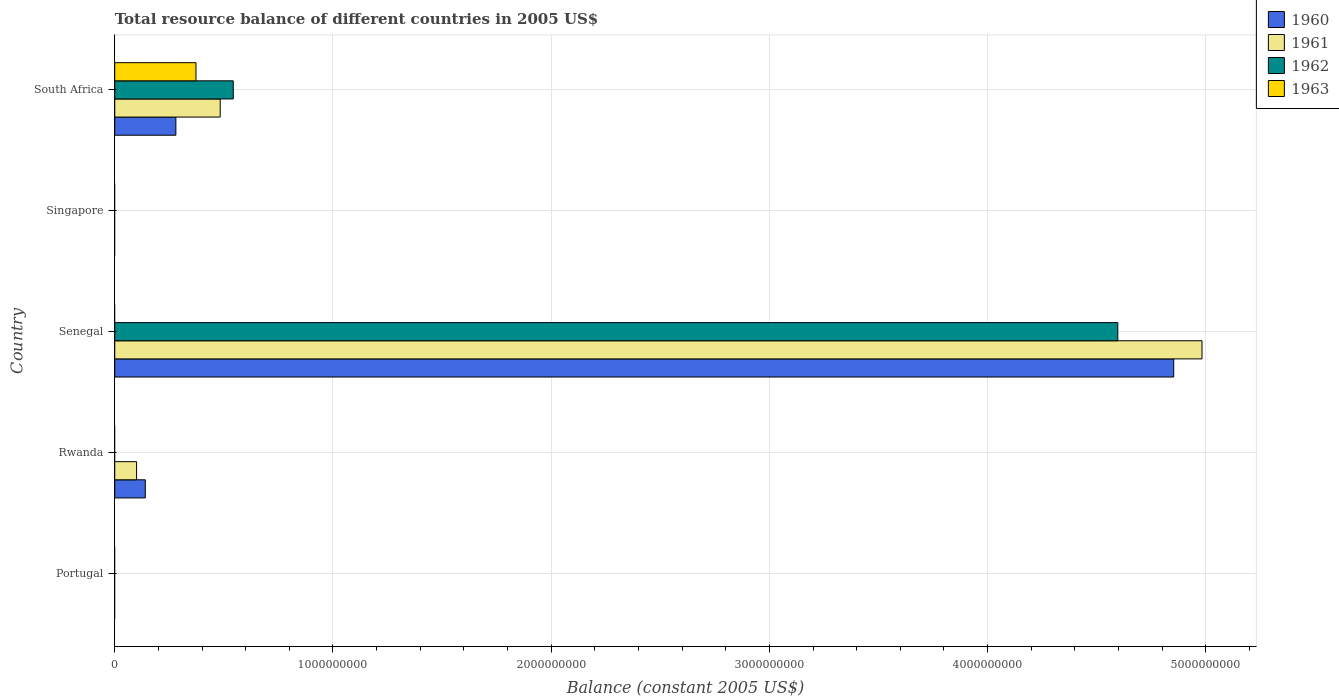How many different coloured bars are there?
Your answer should be compact. 4. Are the number of bars on each tick of the Y-axis equal?
Provide a succinct answer. No. How many bars are there on the 4th tick from the top?
Offer a terse response. 2. How many bars are there on the 1st tick from the bottom?
Your answer should be compact. 0. What is the label of the 4th group of bars from the top?
Offer a very short reply. Rwanda. What is the total resource balance in 1963 in Senegal?
Your response must be concise. 0. Across all countries, what is the maximum total resource balance in 1960?
Provide a short and direct response. 4.85e+09. Across all countries, what is the minimum total resource balance in 1960?
Your answer should be very brief. 0. In which country was the total resource balance in 1963 maximum?
Give a very brief answer. South Africa. What is the total total resource balance in 1961 in the graph?
Offer a terse response. 5.57e+09. What is the difference between the total resource balance in 1960 in Senegal and that in South Africa?
Keep it short and to the point. 4.57e+09. What is the difference between the total resource balance in 1961 in South Africa and the total resource balance in 1960 in Singapore?
Make the answer very short. 4.83e+08. What is the average total resource balance in 1960 per country?
Offer a terse response. 1.05e+09. In how many countries, is the total resource balance in 1962 greater than 3400000000 US$?
Your answer should be compact. 1. What is the difference between the highest and the second highest total resource balance in 1960?
Your answer should be compact. 4.57e+09. What is the difference between the highest and the lowest total resource balance in 1963?
Provide a short and direct response. 3.72e+08. How many bars are there?
Give a very brief answer. 9. How many countries are there in the graph?
Your answer should be very brief. 5. Are the values on the major ticks of X-axis written in scientific E-notation?
Keep it short and to the point. No. Does the graph contain any zero values?
Offer a very short reply. Yes. Does the graph contain grids?
Offer a terse response. Yes. What is the title of the graph?
Your answer should be compact. Total resource balance of different countries in 2005 US$. What is the label or title of the X-axis?
Your answer should be very brief. Balance (constant 2005 US$). What is the Balance (constant 2005 US$) in 1960 in Portugal?
Make the answer very short. 0. What is the Balance (constant 2005 US$) in 1961 in Portugal?
Offer a very short reply. 0. What is the Balance (constant 2005 US$) of 1962 in Portugal?
Your response must be concise. 0. What is the Balance (constant 2005 US$) in 1963 in Portugal?
Provide a short and direct response. 0. What is the Balance (constant 2005 US$) in 1960 in Rwanda?
Keep it short and to the point. 1.40e+08. What is the Balance (constant 2005 US$) of 1960 in Senegal?
Keep it short and to the point. 4.85e+09. What is the Balance (constant 2005 US$) in 1961 in Senegal?
Offer a very short reply. 4.98e+09. What is the Balance (constant 2005 US$) of 1962 in Senegal?
Provide a short and direct response. 4.60e+09. What is the Balance (constant 2005 US$) of 1963 in Senegal?
Ensure brevity in your answer.  0. What is the Balance (constant 2005 US$) in 1961 in Singapore?
Offer a terse response. 0. What is the Balance (constant 2005 US$) of 1962 in Singapore?
Offer a very short reply. 0. What is the Balance (constant 2005 US$) in 1963 in Singapore?
Provide a short and direct response. 0. What is the Balance (constant 2005 US$) of 1960 in South Africa?
Give a very brief answer. 2.80e+08. What is the Balance (constant 2005 US$) in 1961 in South Africa?
Keep it short and to the point. 4.83e+08. What is the Balance (constant 2005 US$) in 1962 in South Africa?
Make the answer very short. 5.43e+08. What is the Balance (constant 2005 US$) of 1963 in South Africa?
Give a very brief answer. 3.72e+08. Across all countries, what is the maximum Balance (constant 2005 US$) in 1960?
Provide a short and direct response. 4.85e+09. Across all countries, what is the maximum Balance (constant 2005 US$) of 1961?
Keep it short and to the point. 4.98e+09. Across all countries, what is the maximum Balance (constant 2005 US$) in 1962?
Offer a very short reply. 4.60e+09. Across all countries, what is the maximum Balance (constant 2005 US$) in 1963?
Provide a succinct answer. 3.72e+08. Across all countries, what is the minimum Balance (constant 2005 US$) in 1960?
Make the answer very short. 0. Across all countries, what is the minimum Balance (constant 2005 US$) of 1961?
Ensure brevity in your answer.  0. Across all countries, what is the minimum Balance (constant 2005 US$) in 1963?
Your answer should be very brief. 0. What is the total Balance (constant 2005 US$) of 1960 in the graph?
Your response must be concise. 5.27e+09. What is the total Balance (constant 2005 US$) in 1961 in the graph?
Keep it short and to the point. 5.57e+09. What is the total Balance (constant 2005 US$) in 1962 in the graph?
Make the answer very short. 5.14e+09. What is the total Balance (constant 2005 US$) of 1963 in the graph?
Make the answer very short. 3.72e+08. What is the difference between the Balance (constant 2005 US$) of 1960 in Rwanda and that in Senegal?
Make the answer very short. -4.71e+09. What is the difference between the Balance (constant 2005 US$) in 1961 in Rwanda and that in Senegal?
Your answer should be compact. -4.88e+09. What is the difference between the Balance (constant 2005 US$) of 1960 in Rwanda and that in South Africa?
Your response must be concise. -1.40e+08. What is the difference between the Balance (constant 2005 US$) in 1961 in Rwanda and that in South Africa?
Your response must be concise. -3.83e+08. What is the difference between the Balance (constant 2005 US$) in 1960 in Senegal and that in South Africa?
Give a very brief answer. 4.57e+09. What is the difference between the Balance (constant 2005 US$) in 1961 in Senegal and that in South Africa?
Offer a terse response. 4.50e+09. What is the difference between the Balance (constant 2005 US$) of 1962 in Senegal and that in South Africa?
Provide a succinct answer. 4.05e+09. What is the difference between the Balance (constant 2005 US$) in 1960 in Rwanda and the Balance (constant 2005 US$) in 1961 in Senegal?
Your answer should be very brief. -4.84e+09. What is the difference between the Balance (constant 2005 US$) of 1960 in Rwanda and the Balance (constant 2005 US$) of 1962 in Senegal?
Provide a succinct answer. -4.46e+09. What is the difference between the Balance (constant 2005 US$) in 1961 in Rwanda and the Balance (constant 2005 US$) in 1962 in Senegal?
Give a very brief answer. -4.50e+09. What is the difference between the Balance (constant 2005 US$) in 1960 in Rwanda and the Balance (constant 2005 US$) in 1961 in South Africa?
Provide a short and direct response. -3.43e+08. What is the difference between the Balance (constant 2005 US$) of 1960 in Rwanda and the Balance (constant 2005 US$) of 1962 in South Africa?
Make the answer very short. -4.03e+08. What is the difference between the Balance (constant 2005 US$) of 1960 in Rwanda and the Balance (constant 2005 US$) of 1963 in South Africa?
Keep it short and to the point. -2.32e+08. What is the difference between the Balance (constant 2005 US$) in 1961 in Rwanda and the Balance (constant 2005 US$) in 1962 in South Africa?
Your answer should be very brief. -4.43e+08. What is the difference between the Balance (constant 2005 US$) in 1961 in Rwanda and the Balance (constant 2005 US$) in 1963 in South Africa?
Offer a very short reply. -2.72e+08. What is the difference between the Balance (constant 2005 US$) of 1960 in Senegal and the Balance (constant 2005 US$) of 1961 in South Africa?
Ensure brevity in your answer.  4.37e+09. What is the difference between the Balance (constant 2005 US$) of 1960 in Senegal and the Balance (constant 2005 US$) of 1962 in South Africa?
Ensure brevity in your answer.  4.31e+09. What is the difference between the Balance (constant 2005 US$) of 1960 in Senegal and the Balance (constant 2005 US$) of 1963 in South Africa?
Offer a very short reply. 4.48e+09. What is the difference between the Balance (constant 2005 US$) of 1961 in Senegal and the Balance (constant 2005 US$) of 1962 in South Africa?
Keep it short and to the point. 4.44e+09. What is the difference between the Balance (constant 2005 US$) in 1961 in Senegal and the Balance (constant 2005 US$) in 1963 in South Africa?
Your answer should be compact. 4.61e+09. What is the difference between the Balance (constant 2005 US$) in 1962 in Senegal and the Balance (constant 2005 US$) in 1963 in South Africa?
Ensure brevity in your answer.  4.22e+09. What is the average Balance (constant 2005 US$) of 1960 per country?
Your answer should be very brief. 1.05e+09. What is the average Balance (constant 2005 US$) of 1961 per country?
Your response must be concise. 1.11e+09. What is the average Balance (constant 2005 US$) of 1962 per country?
Your answer should be very brief. 1.03e+09. What is the average Balance (constant 2005 US$) of 1963 per country?
Provide a short and direct response. 7.44e+07. What is the difference between the Balance (constant 2005 US$) in 1960 and Balance (constant 2005 US$) in 1961 in Rwanda?
Provide a succinct answer. 4.00e+07. What is the difference between the Balance (constant 2005 US$) of 1960 and Balance (constant 2005 US$) of 1961 in Senegal?
Your response must be concise. -1.30e+08. What is the difference between the Balance (constant 2005 US$) of 1960 and Balance (constant 2005 US$) of 1962 in Senegal?
Offer a very short reply. 2.56e+08. What is the difference between the Balance (constant 2005 US$) in 1961 and Balance (constant 2005 US$) in 1962 in Senegal?
Offer a very short reply. 3.86e+08. What is the difference between the Balance (constant 2005 US$) in 1960 and Balance (constant 2005 US$) in 1961 in South Africa?
Provide a succinct answer. -2.03e+08. What is the difference between the Balance (constant 2005 US$) in 1960 and Balance (constant 2005 US$) in 1962 in South Africa?
Offer a very short reply. -2.63e+08. What is the difference between the Balance (constant 2005 US$) in 1960 and Balance (constant 2005 US$) in 1963 in South Africa?
Keep it short and to the point. -9.21e+07. What is the difference between the Balance (constant 2005 US$) of 1961 and Balance (constant 2005 US$) of 1962 in South Africa?
Give a very brief answer. -5.99e+07. What is the difference between the Balance (constant 2005 US$) in 1961 and Balance (constant 2005 US$) in 1963 in South Africa?
Offer a terse response. 1.11e+08. What is the difference between the Balance (constant 2005 US$) of 1962 and Balance (constant 2005 US$) of 1963 in South Africa?
Offer a very short reply. 1.71e+08. What is the ratio of the Balance (constant 2005 US$) of 1960 in Rwanda to that in Senegal?
Provide a succinct answer. 0.03. What is the ratio of the Balance (constant 2005 US$) of 1961 in Rwanda to that in Senegal?
Your answer should be very brief. 0.02. What is the ratio of the Balance (constant 2005 US$) of 1960 in Rwanda to that in South Africa?
Your response must be concise. 0.5. What is the ratio of the Balance (constant 2005 US$) of 1961 in Rwanda to that in South Africa?
Your response must be concise. 0.21. What is the ratio of the Balance (constant 2005 US$) of 1960 in Senegal to that in South Africa?
Your answer should be compact. 17.33. What is the ratio of the Balance (constant 2005 US$) in 1961 in Senegal to that in South Africa?
Offer a very short reply. 10.31. What is the ratio of the Balance (constant 2005 US$) in 1962 in Senegal to that in South Africa?
Ensure brevity in your answer.  8.46. What is the difference between the highest and the second highest Balance (constant 2005 US$) in 1960?
Provide a succinct answer. 4.57e+09. What is the difference between the highest and the second highest Balance (constant 2005 US$) in 1961?
Provide a short and direct response. 4.50e+09. What is the difference between the highest and the lowest Balance (constant 2005 US$) in 1960?
Make the answer very short. 4.85e+09. What is the difference between the highest and the lowest Balance (constant 2005 US$) in 1961?
Make the answer very short. 4.98e+09. What is the difference between the highest and the lowest Balance (constant 2005 US$) in 1962?
Your answer should be very brief. 4.60e+09. What is the difference between the highest and the lowest Balance (constant 2005 US$) of 1963?
Offer a terse response. 3.72e+08. 